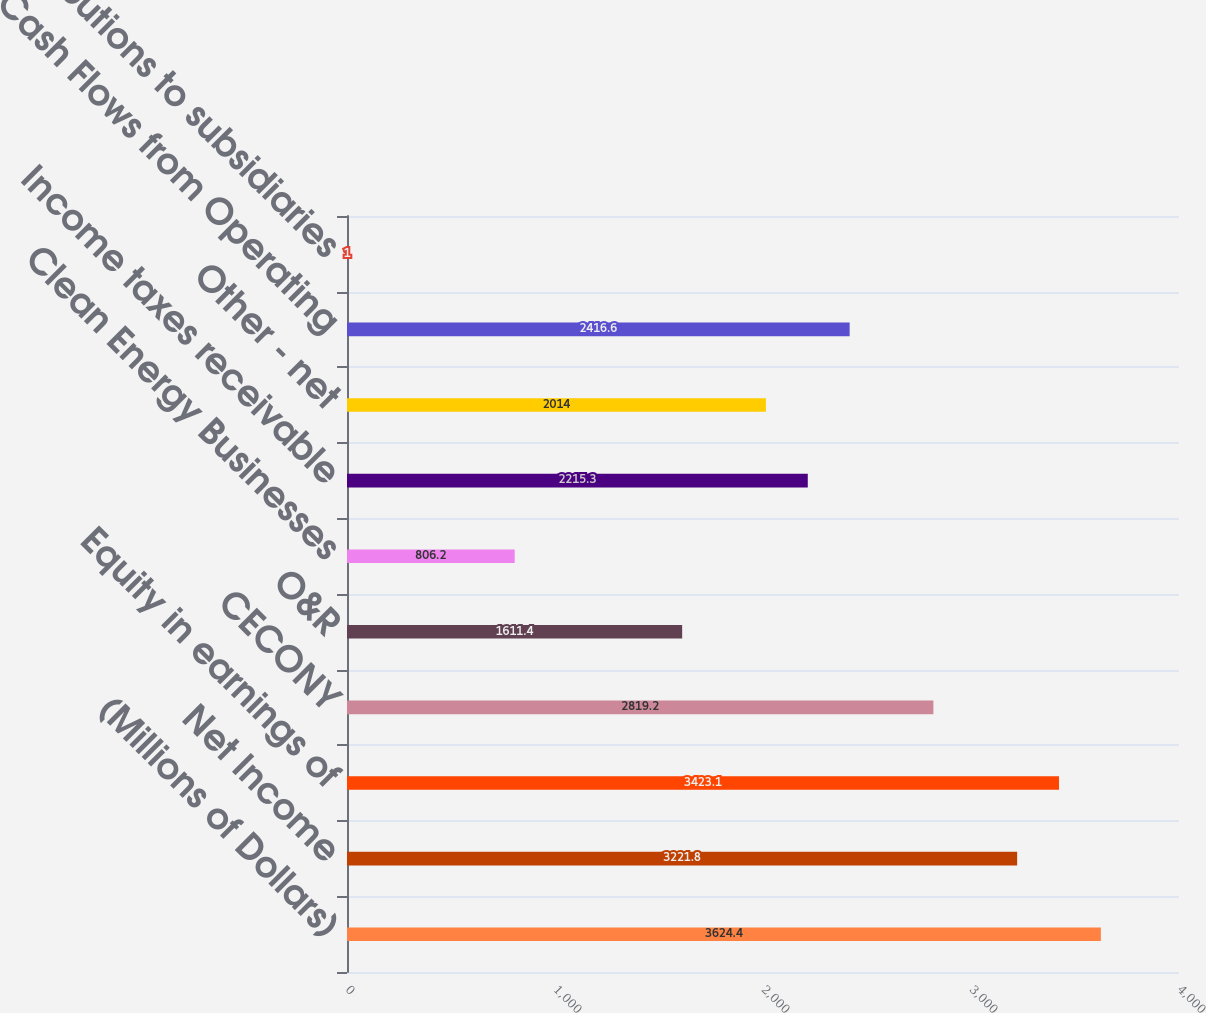<chart> <loc_0><loc_0><loc_500><loc_500><bar_chart><fcel>(Millions of Dollars)<fcel>Net Income<fcel>Equity in earnings of<fcel>CECONY<fcel>O&R<fcel>Clean Energy Businesses<fcel>Income taxes receivable<fcel>Other - net<fcel>Net Cash Flows from Operating<fcel>Contributions to subsidiaries<nl><fcel>3624.4<fcel>3221.8<fcel>3423.1<fcel>2819.2<fcel>1611.4<fcel>806.2<fcel>2215.3<fcel>2014<fcel>2416.6<fcel>1<nl></chart> 